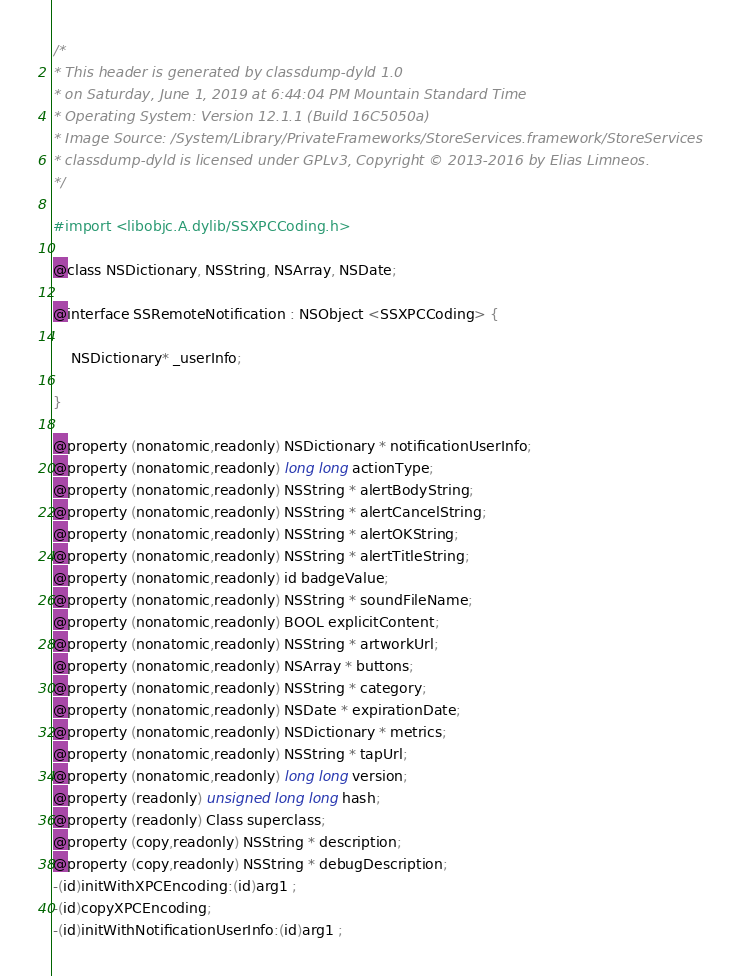Convert code to text. <code><loc_0><loc_0><loc_500><loc_500><_C_>/*
* This header is generated by classdump-dyld 1.0
* on Saturday, June 1, 2019 at 6:44:04 PM Mountain Standard Time
* Operating System: Version 12.1.1 (Build 16C5050a)
* Image Source: /System/Library/PrivateFrameworks/StoreServices.framework/StoreServices
* classdump-dyld is licensed under GPLv3, Copyright © 2013-2016 by Elias Limneos.
*/

#import <libobjc.A.dylib/SSXPCCoding.h>

@class NSDictionary, NSString, NSArray, NSDate;

@interface SSRemoteNotification : NSObject <SSXPCCoding> {

	NSDictionary* _userInfo;

}

@property (nonatomic,readonly) NSDictionary * notificationUserInfo; 
@property (nonatomic,readonly) long long actionType; 
@property (nonatomic,readonly) NSString * alertBodyString; 
@property (nonatomic,readonly) NSString * alertCancelString; 
@property (nonatomic,readonly) NSString * alertOKString; 
@property (nonatomic,readonly) NSString * alertTitleString; 
@property (nonatomic,readonly) id badgeValue; 
@property (nonatomic,readonly) NSString * soundFileName; 
@property (nonatomic,readonly) BOOL explicitContent; 
@property (nonatomic,readonly) NSString * artworkUrl; 
@property (nonatomic,readonly) NSArray * buttons; 
@property (nonatomic,readonly) NSString * category; 
@property (nonatomic,readonly) NSDate * expirationDate; 
@property (nonatomic,readonly) NSDictionary * metrics; 
@property (nonatomic,readonly) NSString * tapUrl; 
@property (nonatomic,readonly) long long version; 
@property (readonly) unsigned long long hash; 
@property (readonly) Class superclass; 
@property (copy,readonly) NSString * description; 
@property (copy,readonly) NSString * debugDescription; 
-(id)initWithXPCEncoding:(id)arg1 ;
-(id)copyXPCEncoding;
-(id)initWithNotificationUserInfo:(id)arg1 ;</code> 